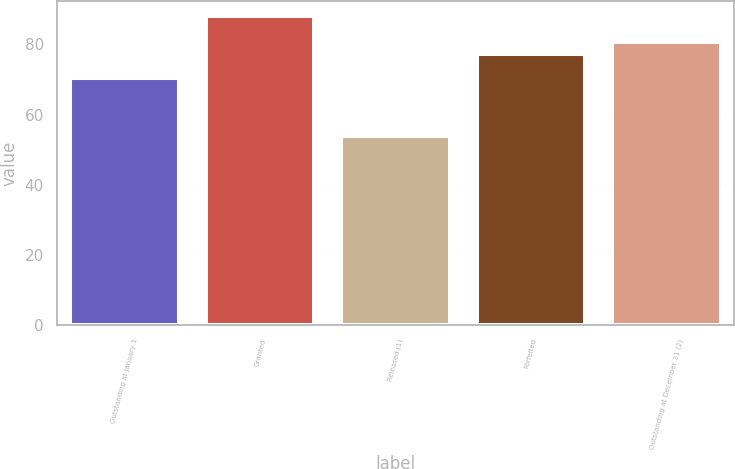Convert chart to OTSL. <chart><loc_0><loc_0><loc_500><loc_500><bar_chart><fcel>Outstanding at January 1<fcel>Granted<fcel>Released (1)<fcel>Forfeited<fcel>Outstanding at December 31 (2)<nl><fcel>70.35<fcel>88.01<fcel>53.95<fcel>77.29<fcel>80.7<nl></chart> 